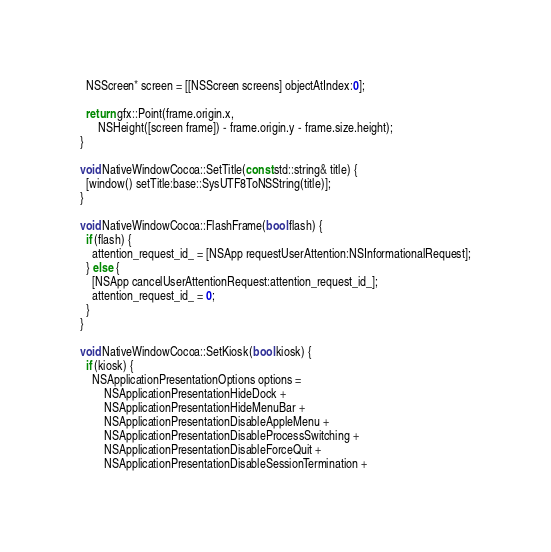Convert code to text. <code><loc_0><loc_0><loc_500><loc_500><_ObjectiveC_>  NSScreen* screen = [[NSScreen screens] objectAtIndex:0];

  return gfx::Point(frame.origin.x,
      NSHeight([screen frame]) - frame.origin.y - frame.size.height);
}

void NativeWindowCocoa::SetTitle(const std::string& title) {
  [window() setTitle:base::SysUTF8ToNSString(title)];
}

void NativeWindowCocoa::FlashFrame(bool flash) {
  if (flash) {
    attention_request_id_ = [NSApp requestUserAttention:NSInformationalRequest];
  } else {
    [NSApp cancelUserAttentionRequest:attention_request_id_];
    attention_request_id_ = 0;
  }
}

void NativeWindowCocoa::SetKiosk(bool kiosk) {
  if (kiosk) {
    NSApplicationPresentationOptions options =
        NSApplicationPresentationHideDock +
        NSApplicationPresentationHideMenuBar + 
        NSApplicationPresentationDisableAppleMenu +
        NSApplicationPresentationDisableProcessSwitching +
        NSApplicationPresentationDisableForceQuit +
        NSApplicationPresentationDisableSessionTermination +</code> 